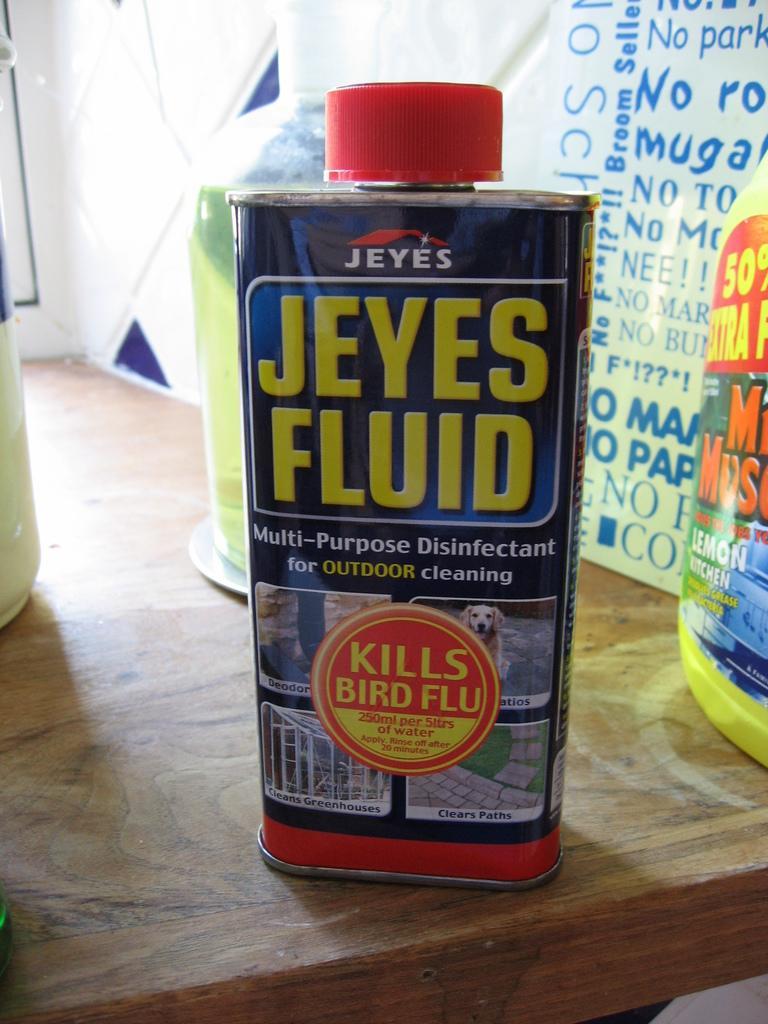Please provide a concise description of this image. In this image there is a table and we can see a tin and bottles placed on the table. In the background there is a board and we can see a wall. 